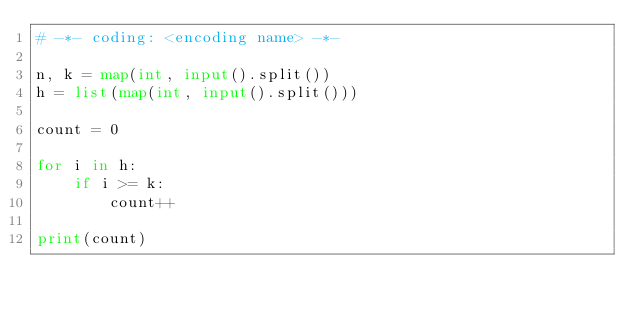Convert code to text. <code><loc_0><loc_0><loc_500><loc_500><_Python_># -*- coding: <encoding name> -*-

n, k = map(int, input().split())
h = list(map(int, input().split()))

count = 0

for i in h:
	if i >= k:
		count++

print(count)</code> 